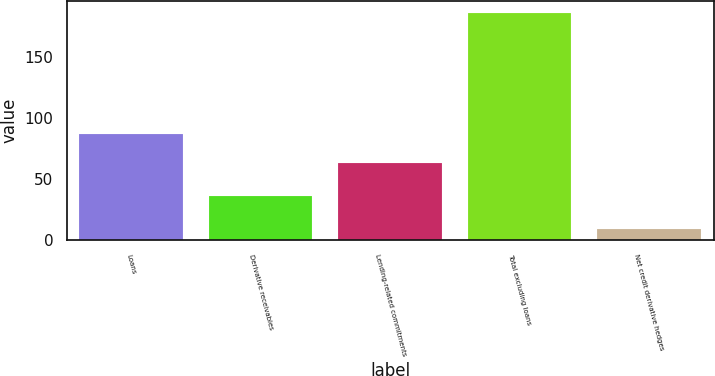Convert chart to OTSL. <chart><loc_0><loc_0><loc_500><loc_500><bar_chart><fcel>Loans<fcel>Derivative receivables<fcel>Lending-related commitments<fcel>Total excluding loans<fcel>Net credit derivative hedges<nl><fcel>87<fcel>36<fcel>63<fcel>186<fcel>9<nl></chart> 